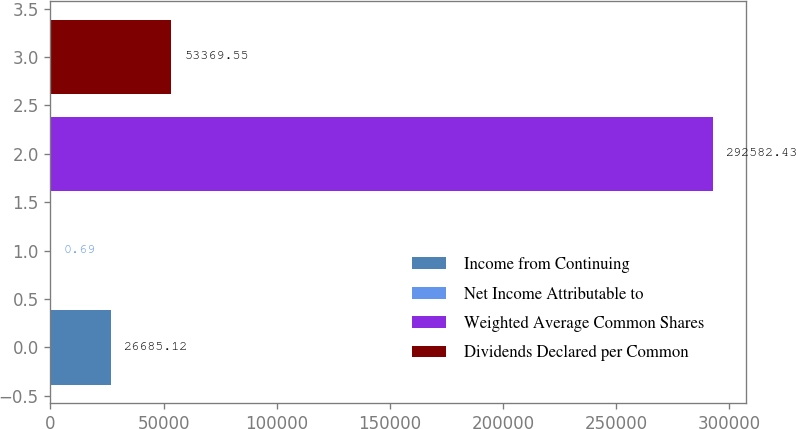Convert chart. <chart><loc_0><loc_0><loc_500><loc_500><bar_chart><fcel>Income from Continuing<fcel>Net Income Attributable to<fcel>Weighted Average Common Shares<fcel>Dividends Declared per Common<nl><fcel>26685.1<fcel>0.69<fcel>292582<fcel>53369.6<nl></chart> 